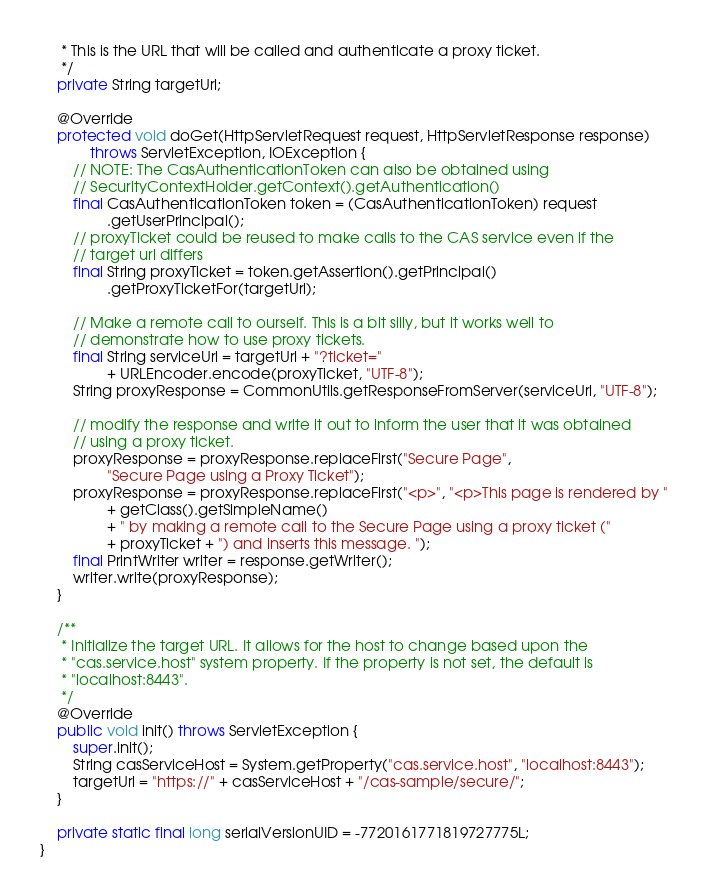<code> <loc_0><loc_0><loc_500><loc_500><_Java_>	 * This is the URL that will be called and authenticate a proxy ticket.
	 */
	private String targetUrl;

	@Override
	protected void doGet(HttpServletRequest request, HttpServletResponse response)
			throws ServletException, IOException {
		// NOTE: The CasAuthenticationToken can also be obtained using
		// SecurityContextHolder.getContext().getAuthentication()
		final CasAuthenticationToken token = (CasAuthenticationToken) request
				.getUserPrincipal();
		// proxyTicket could be reused to make calls to the CAS service even if the
		// target url differs
		final String proxyTicket = token.getAssertion().getPrincipal()
				.getProxyTicketFor(targetUrl);

		// Make a remote call to ourself. This is a bit silly, but it works well to
		// demonstrate how to use proxy tickets.
		final String serviceUrl = targetUrl + "?ticket="
				+ URLEncoder.encode(proxyTicket, "UTF-8");
		String proxyResponse = CommonUtils.getResponseFromServer(serviceUrl, "UTF-8");

		// modify the response and write it out to inform the user that it was obtained
		// using a proxy ticket.
		proxyResponse = proxyResponse.replaceFirst("Secure Page",
				"Secure Page using a Proxy Ticket");
		proxyResponse = proxyResponse.replaceFirst("<p>", "<p>This page is rendered by "
				+ getClass().getSimpleName()
				+ " by making a remote call to the Secure Page using a proxy ticket ("
				+ proxyTicket + ") and inserts this message. ");
		final PrintWriter writer = response.getWriter();
		writer.write(proxyResponse);
	}

	/**
	 * Initialize the target URL. It allows for the host to change based upon the
	 * "cas.service.host" system property. If the property is not set, the default is
	 * "localhost:8443".
	 */
	@Override
	public void init() throws ServletException {
		super.init();
		String casServiceHost = System.getProperty("cas.service.host", "localhost:8443");
		targetUrl = "https://" + casServiceHost + "/cas-sample/secure/";
	}

	private static final long serialVersionUID = -7720161771819727775L;
}
</code> 